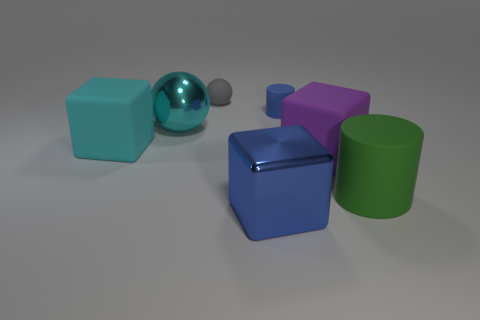The gray thing that is the same material as the purple thing is what size?
Offer a very short reply. Small. Are there more big matte cubes on the left side of the blue cylinder than small blue objects on the left side of the shiny sphere?
Keep it short and to the point. Yes. How many other objects are the same material as the cyan sphere?
Ensure brevity in your answer.  1. Is the small thing left of the large blue object made of the same material as the green thing?
Your answer should be compact. Yes. What is the shape of the blue metallic object?
Your answer should be very brief. Cube. Are there more cubes that are left of the big blue shiny cube than things?
Offer a very short reply. No. Is there anything else that has the same shape as the cyan rubber object?
Offer a very short reply. Yes. There is a metal object that is the same shape as the big cyan matte thing; what is its color?
Your answer should be compact. Blue. The big rubber object left of the large purple block has what shape?
Ensure brevity in your answer.  Cube. Are there any blocks in front of the large blue metallic block?
Keep it short and to the point. No. 